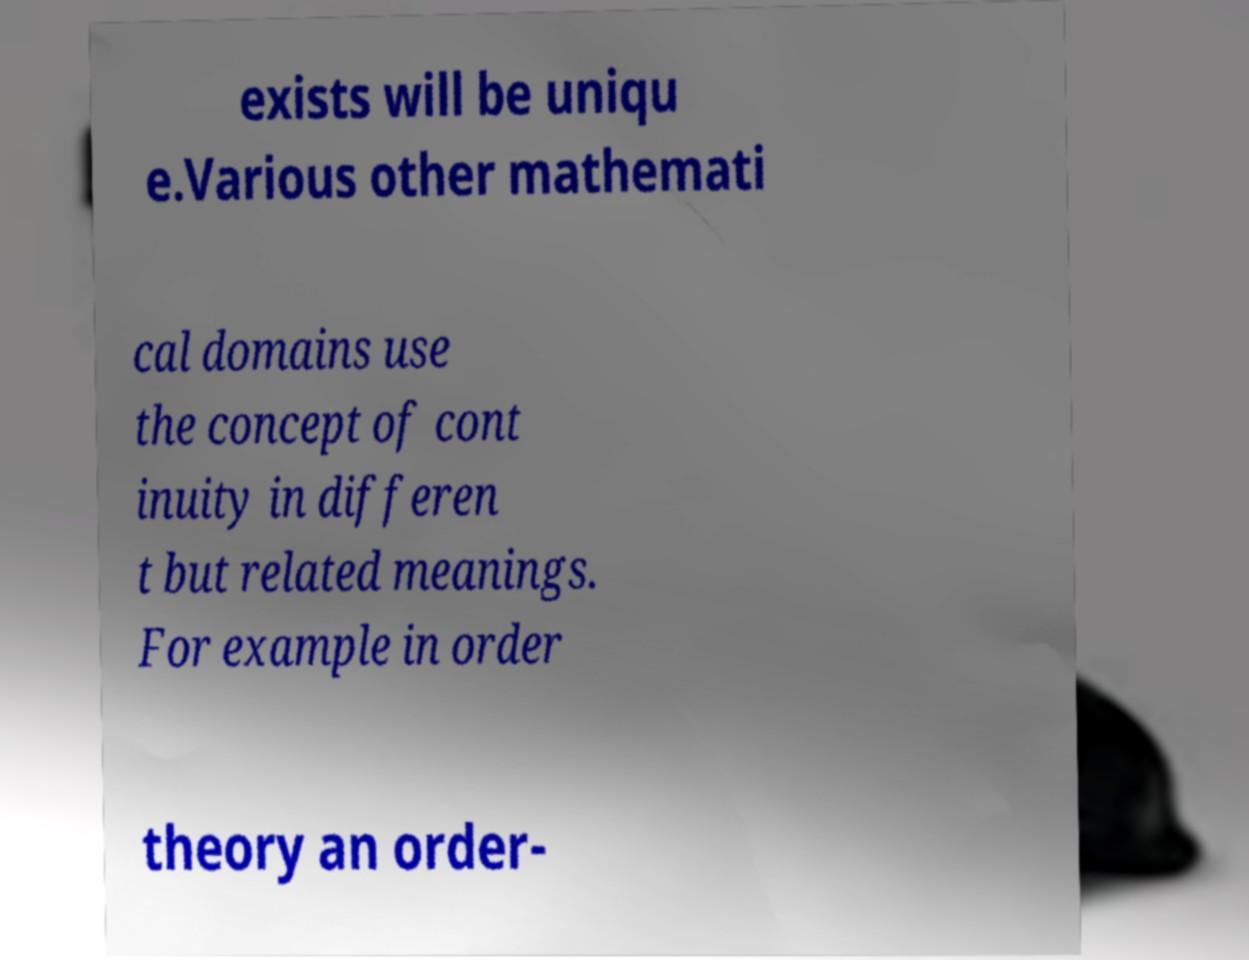Please read and relay the text visible in this image. What does it say? exists will be uniqu e.Various other mathemati cal domains use the concept of cont inuity in differen t but related meanings. For example in order theory an order- 